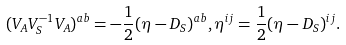<formula> <loc_0><loc_0><loc_500><loc_500>( V _ { A } V _ { S } ^ { - 1 } V _ { A } ) ^ { a b } = - \frac { 1 } { 2 } ( \eta - D _ { S } ) ^ { a b } , \eta ^ { i j } = \frac { 1 } { 2 } ( \eta - D _ { S } ) ^ { i j } .</formula> 